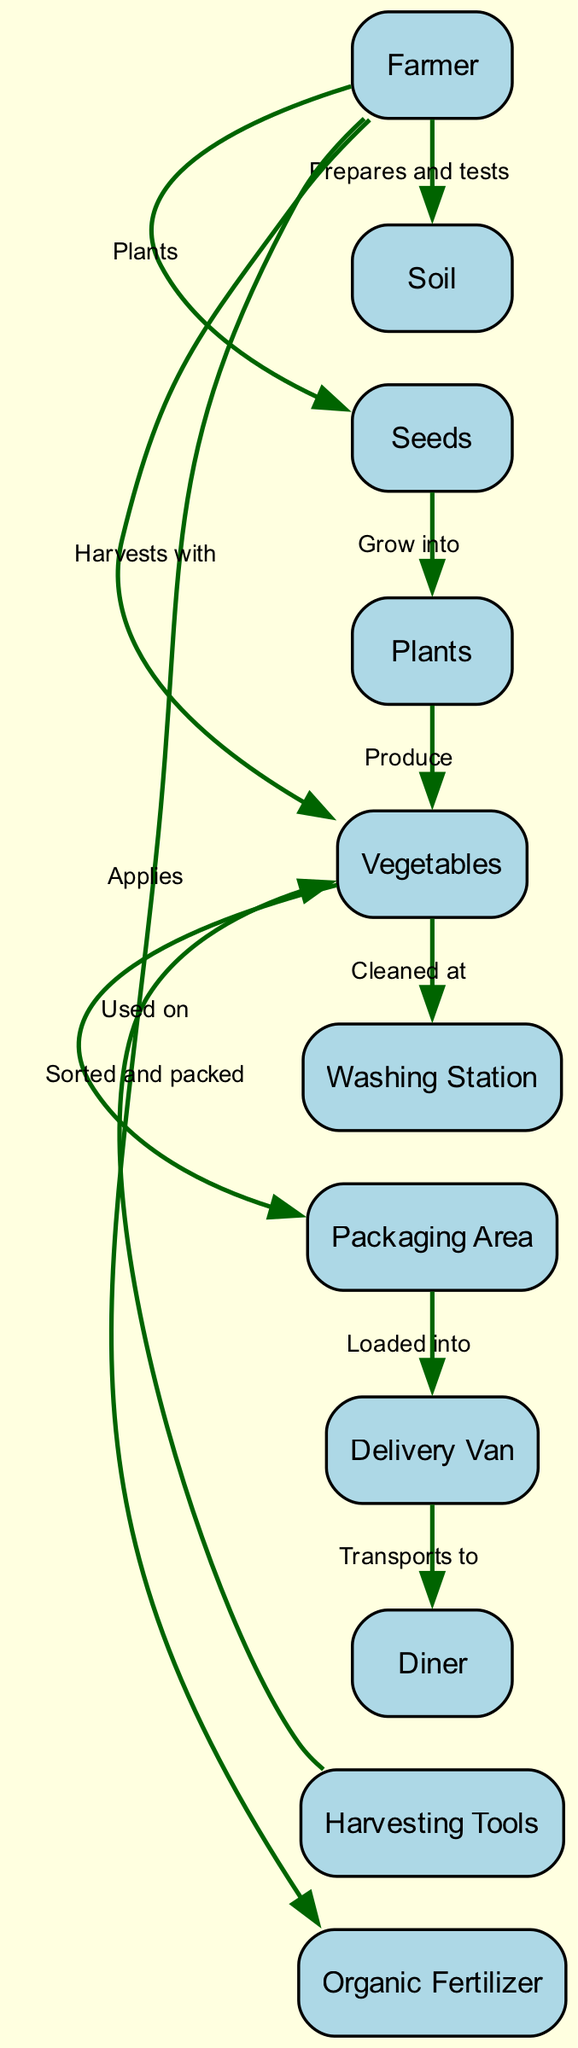What is the first action in the sequence? The diagram indicates that the very first action is when the Farmer prepares and tests the Soil. This can be observed from the first arrow pointing from the Farmer to the Soil with the action labeled "Prepares and tests."
Answer: Prepares and tests How many entities are in the diagram? By counting the distinct entities listed in the diagram, we find a total of ten entities: Farmer, Soil, Seeds, Organic Fertilizer, Plants, Vegetables, Harvesting Tools, Washing Station, Packaging Area, and Delivery Van.
Answer: Ten What action follows the planting of seeds? After the Farmer plants the Seeds, the next action is that the Seeds grow into Plants. This relationship is shown in the diagram with an arrow from Seeds to Plants labeled "Grow into."
Answer: Grow into Which entity is responsible for applying organic fertilizer? The diagram clearly shows that the Farmer applies Organic Fertilizer. This is represented by the action connecting the Farmer to Organic Fertilizer with the action "Applies."
Answer: Farmer What is the last action in the lifecycle before reaching the diner? The last action shown in the sequence is that the Delivery Van transports the products to the Diner. This relationship is demonstrated by an arrow from Delivery Van to Diner labeled "Transports to."
Answer: Transports to How many steps are there between planting and delivery to the diner? The sequence consists of six steps from planting the Seeds to delivery at the Diner. These include planting, applying fertilizer, growing, producing vegetables, harvesting, and transporting to the diner.
Answer: Six Which tools are used for harvesting? The Harvesting Tools are specifically mentioned in the action where the Farmer harvests the Vegetables. This is illustrated by the connection between Harvesting Tools and Vegetables with the action "Used on."
Answer: Harvesting Tools What comes after cleaning the vegetables? After the Vegetables are cleaned at the Washing Station, they are sorted and packed at the Packaging Area. The diagram shows this as an action flowing from Washing Station to Packaging Area labeled "Sorted and packed."
Answer: Sorted and packed What is the role of the Packaging Area in the lifecycle? The Packaging Area is responsible for sorting and packing the Vegetables before they are loaded into the Delivery Van. This role is depicted in the diagram by the connection from Vegetables to Packaging Area with the action "Sorted and packed."
Answer: Sorted and packed 